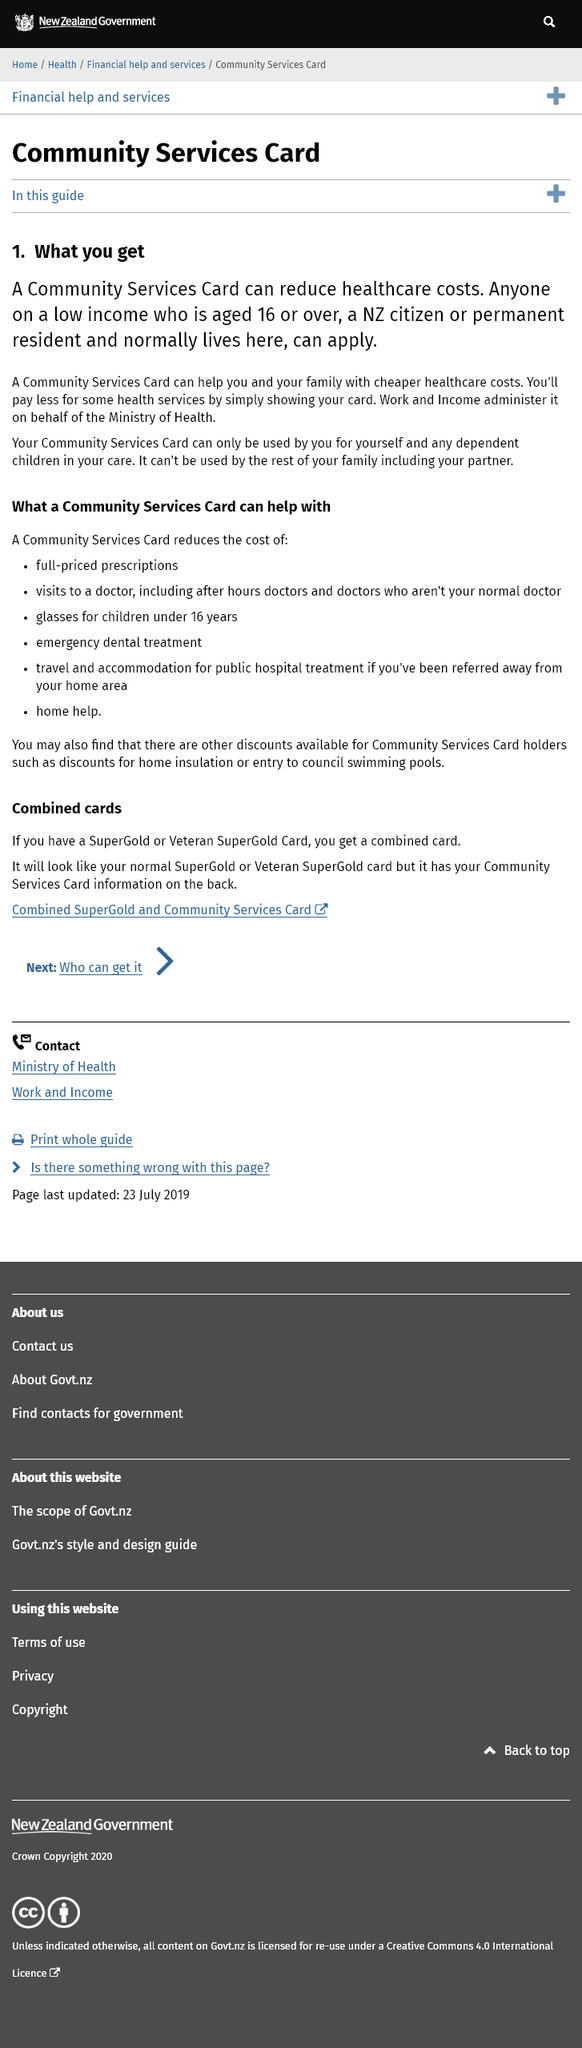Indicate a few pertinent items in this graphic. You will pay less for some health services simply by showing your card, yes, it is true. Only individuals who are 16 years of age or older are eligible to obtain a Community Services Card. The card designed to decrease healthcare expenses can only be used by the individual and their dependent children and cannot be used by anyone else. 